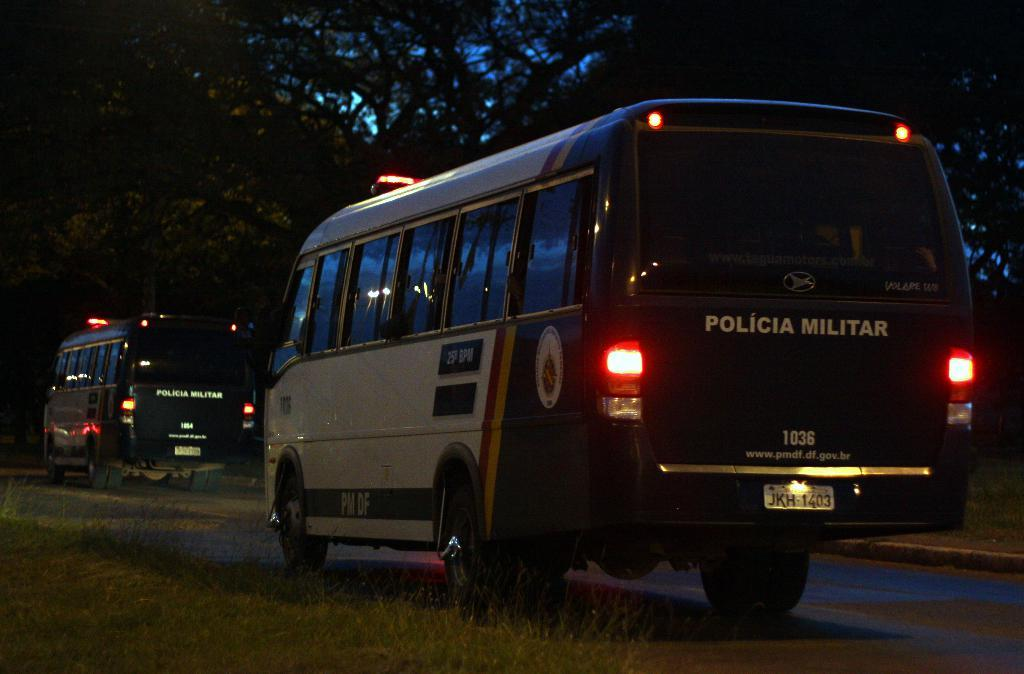How many vehicles can be seen on the road in the image? There are two vehicles on the road in the image. What can be seen in the background of the image? There are trees visible in the background of the image. What flavor of guitar can be seen in the image? There is no guitar present in the image, so it is not possible to determine its flavor. 